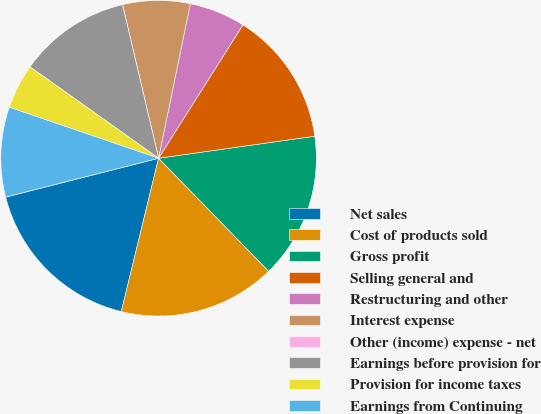Convert chart to OTSL. <chart><loc_0><loc_0><loc_500><loc_500><pie_chart><fcel>Net sales<fcel>Cost of products sold<fcel>Gross profit<fcel>Selling general and<fcel>Restructuring and other<fcel>Interest expense<fcel>Other (income) expense - net<fcel>Earnings before provision for<fcel>Provision for income taxes<fcel>Earnings from Continuing<nl><fcel>17.24%<fcel>16.09%<fcel>14.94%<fcel>13.79%<fcel>5.75%<fcel>6.9%<fcel>0.0%<fcel>11.49%<fcel>4.6%<fcel>9.2%<nl></chart> 